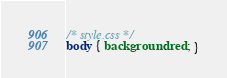Convert code to text. <code><loc_0><loc_0><loc_500><loc_500><_CSS_>/* style.css */
body { background: red; }</code> 